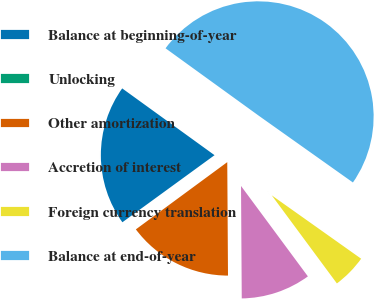<chart> <loc_0><loc_0><loc_500><loc_500><pie_chart><fcel>Balance at beginning-of-year<fcel>Unlocking<fcel>Other amortization<fcel>Accretion of interest<fcel>Foreign currency translation<fcel>Balance at end-of-year<nl><fcel>19.98%<fcel>0.08%<fcel>15.01%<fcel>10.03%<fcel>5.05%<fcel>49.85%<nl></chart> 